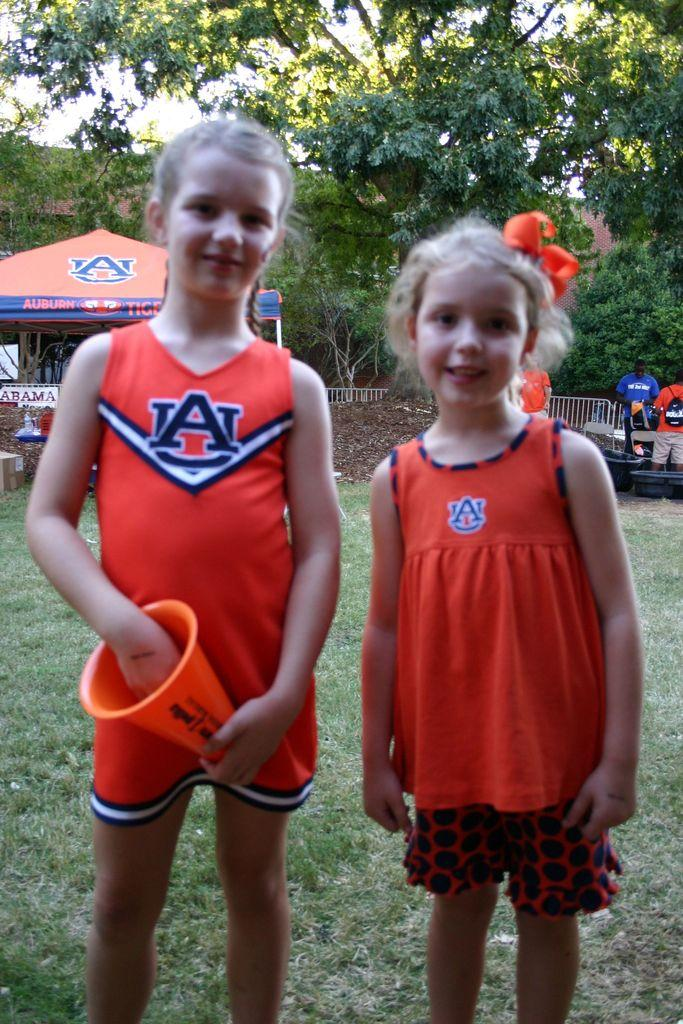Provide a one-sentence caption for the provided image. Two young girls wearing UA shirts standing in front of a tent. 